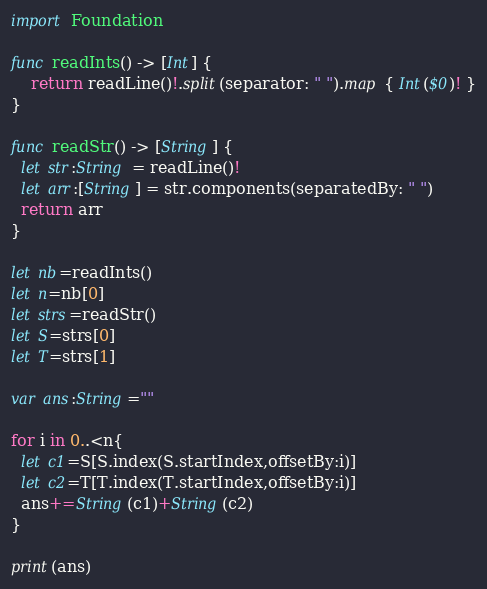<code> <loc_0><loc_0><loc_500><loc_500><_Swift_>import Foundation

func readInts() -> [Int] {
    return readLine()!.split(separator: " ").map { Int($0)! }
}

func readStr() -> [String] {
  let str:String = readLine()!
  let arr:[String] = str.components(separatedBy: " ")
  return arr
}

let nb=readInts()
let n=nb[0]
let strs=readStr()
let S=strs[0]
let T=strs[1]

var ans:String=""

for i in 0..<n{
  let c1=S[S.index(S.startIndex,offsetBy:i)]
  let c2=T[T.index(T.startIndex,offsetBy:i)]
  ans+=String(c1)+String(c2)
}

print(ans)</code> 